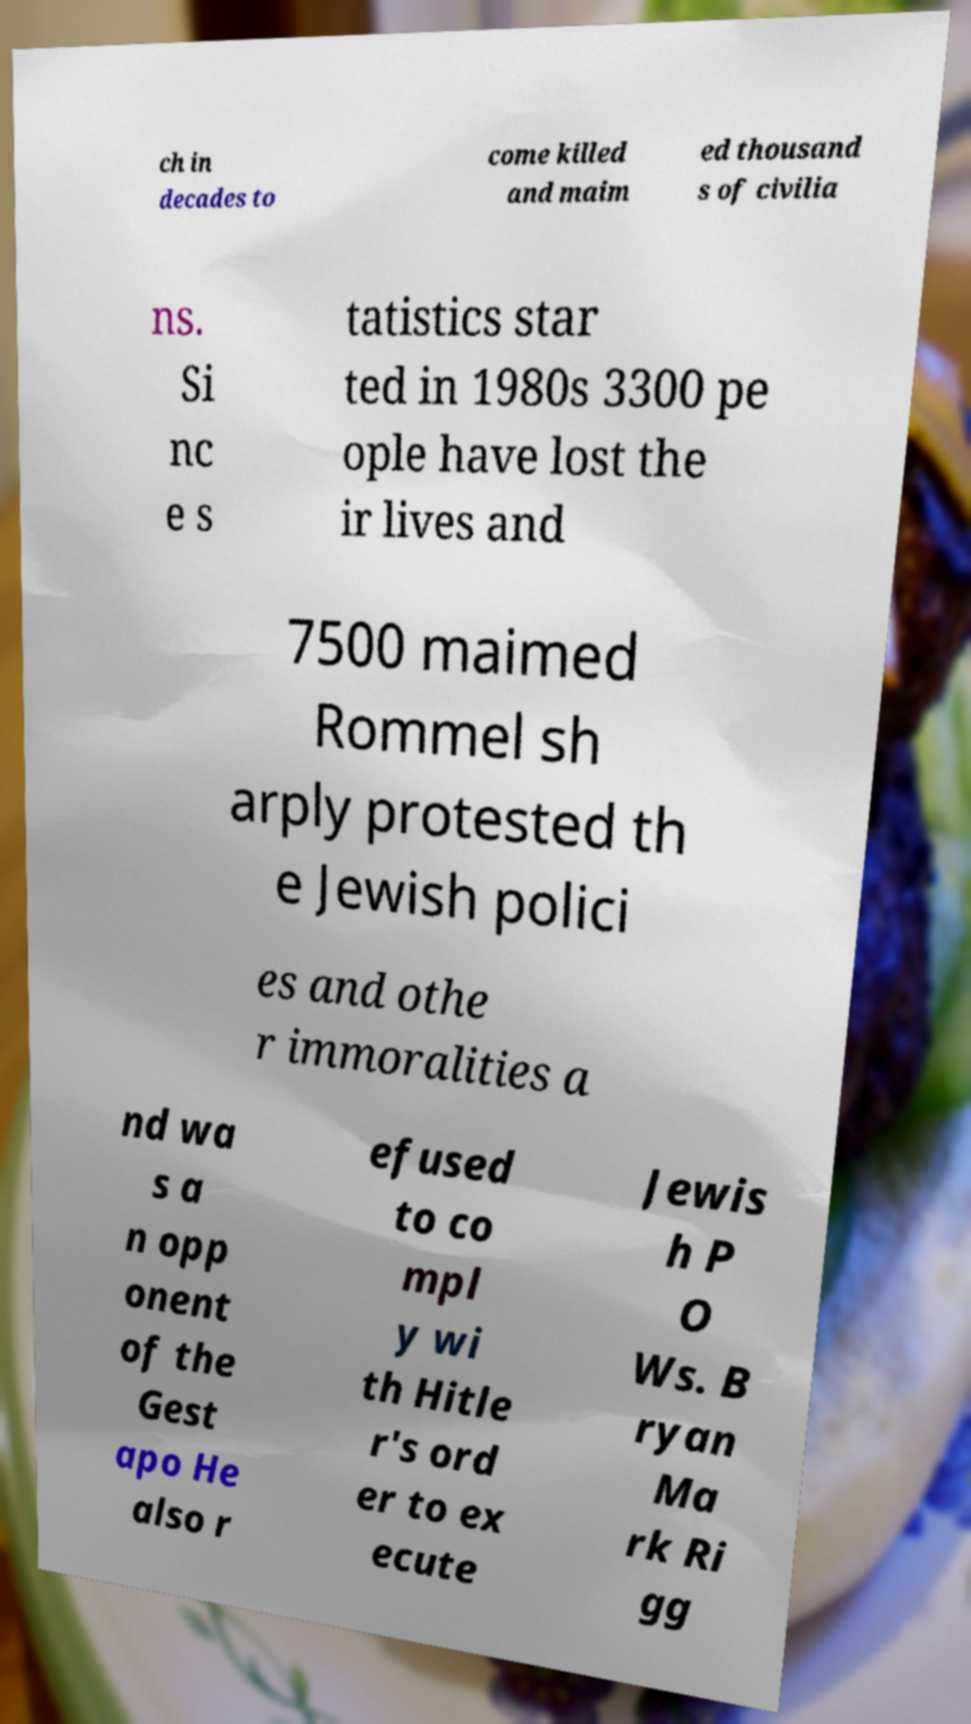There's text embedded in this image that I need extracted. Can you transcribe it verbatim? ch in decades to come killed and maim ed thousand s of civilia ns. Si nc e s tatistics star ted in 1980s 3300 pe ople have lost the ir lives and 7500 maimed Rommel sh arply protested th e Jewish polici es and othe r immoralities a nd wa s a n opp onent of the Gest apo He also r efused to co mpl y wi th Hitle r's ord er to ex ecute Jewis h P O Ws. B ryan Ma rk Ri gg 